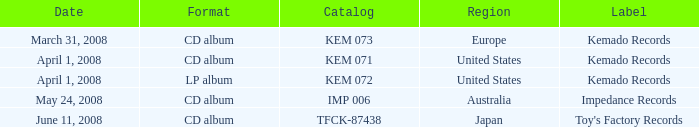Which Format has a Label of toy's factory records? CD album. 